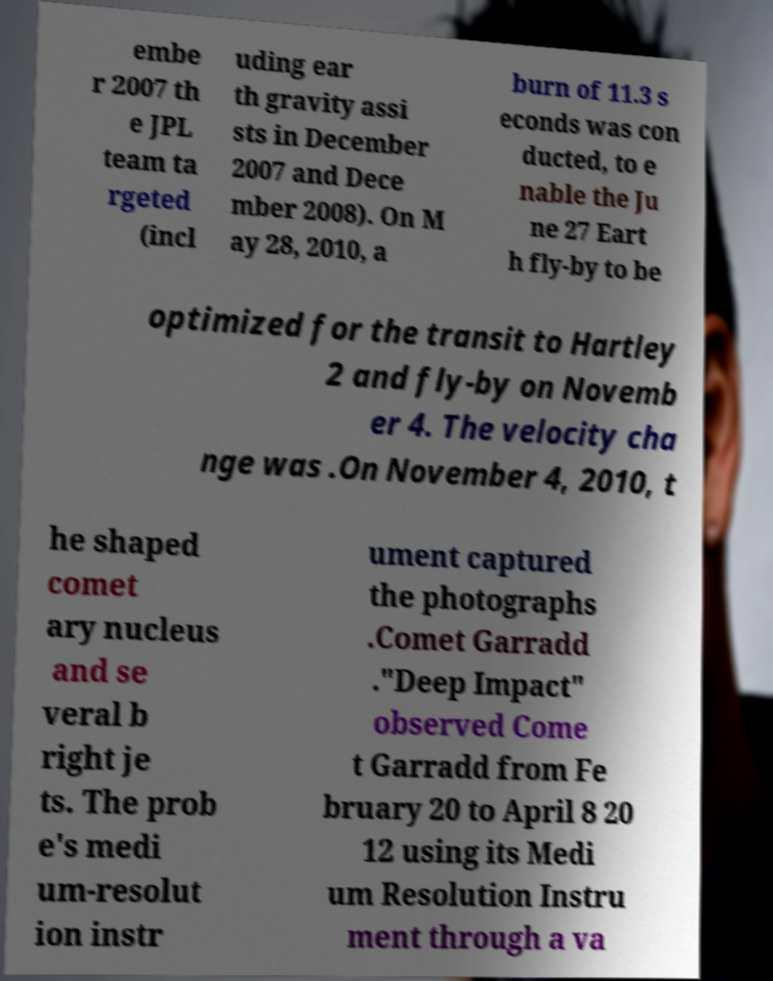There's text embedded in this image that I need extracted. Can you transcribe it verbatim? embe r 2007 th e JPL team ta rgeted (incl uding ear th gravity assi sts in December 2007 and Dece mber 2008). On M ay 28, 2010, a burn of 11.3 s econds was con ducted, to e nable the Ju ne 27 Eart h fly-by to be optimized for the transit to Hartley 2 and fly-by on Novemb er 4. The velocity cha nge was .On November 4, 2010, t he shaped comet ary nucleus and se veral b right je ts. The prob e's medi um-resolut ion instr ument captured the photographs .Comet Garradd ."Deep Impact" observed Come t Garradd from Fe bruary 20 to April 8 20 12 using its Medi um Resolution Instru ment through a va 